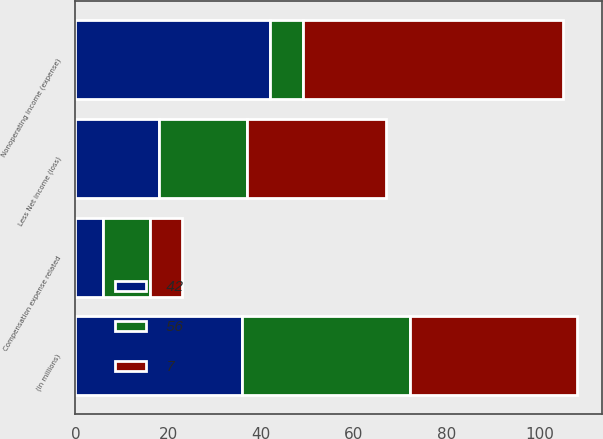Convert chart. <chart><loc_0><loc_0><loc_500><loc_500><stacked_bar_chart><ecel><fcel>(in millions)<fcel>Nonoperating income (expense)<fcel>Less Net income (loss)<fcel>Compensation expense related<nl><fcel>7<fcel>36<fcel>56<fcel>30<fcel>7<nl><fcel>56<fcel>36<fcel>7<fcel>19<fcel>10<nl><fcel>42<fcel>36<fcel>42<fcel>18<fcel>6<nl></chart> 